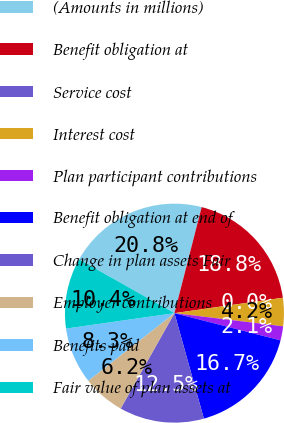Convert chart. <chart><loc_0><loc_0><loc_500><loc_500><pie_chart><fcel>(Amounts in millions)<fcel>Benefit obligation at<fcel>Service cost<fcel>Interest cost<fcel>Plan participant contributions<fcel>Benefit obligation at end of<fcel>Change in plan assets Fair<fcel>Employer contributions<fcel>Benefits paid<fcel>Fair value of plan assets at<nl><fcel>20.83%<fcel>18.75%<fcel>0.0%<fcel>4.17%<fcel>2.08%<fcel>16.67%<fcel>12.5%<fcel>6.25%<fcel>8.33%<fcel>10.42%<nl></chart> 